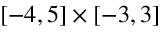Convert formula to latex. <formula><loc_0><loc_0><loc_500><loc_500>[ - 4 , 5 ] \times [ - 3 , 3 ]</formula> 